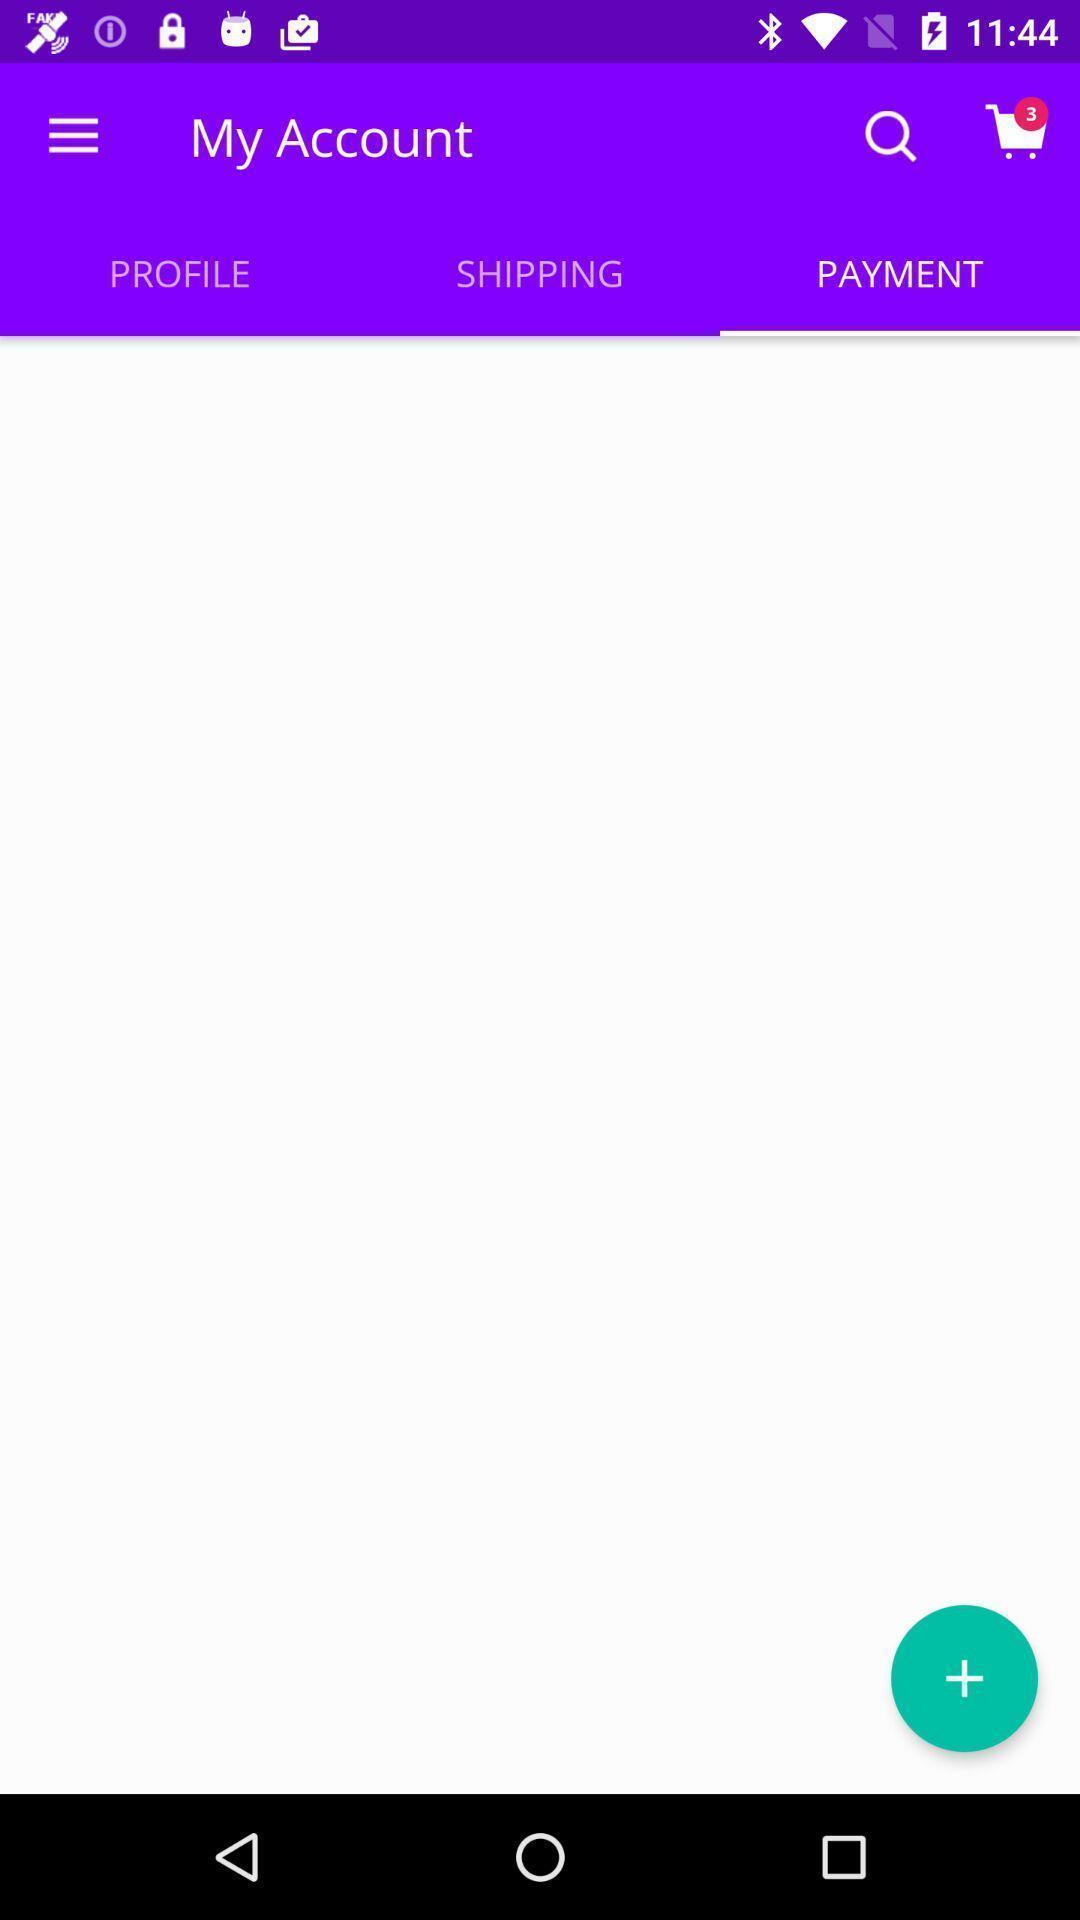What details can you identify in this image? Screen displaying payments page contents in a shopping application. 